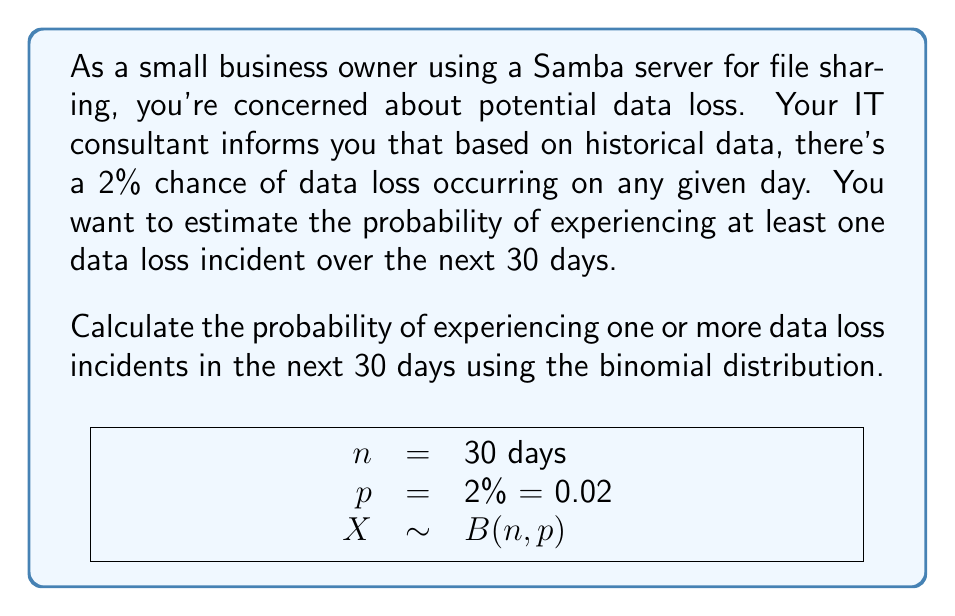Solve this math problem. Let's approach this step-by-step using the binomial distribution:

1) Define the variables:
   $n$ = number of days = 30
   $p$ = probability of data loss on a single day = 0.02
   $X$ = number of data loss incidents

2) We want to find $P(X \geq 1)$, which is equivalent to $1 - P(X = 0)$

3) The probability mass function for the binomial distribution is:

   $$P(X = k) = \binom{n}{k} p^k (1-p)^{n-k}$$

4) For $P(X = 0)$:

   $$P(X = 0) = \binom{30}{0} (0.02)^0 (1-0.02)^{30}$$

5) Simplify:
   $$P(X = 0) = 1 \cdot 1 \cdot (0.98)^{30}$$

6) Calculate:
   $$P(X = 0) = (0.98)^{30} \approx 0.5475$$

7) Therefore, $P(X \geq 1) = 1 - P(X = 0)$:
   $$P(X \geq 1) = 1 - 0.5475 \approx 0.4525$$

8) Convert to percentage:
   0.4525 * 100 = 45.25%
Answer: 45.25% 